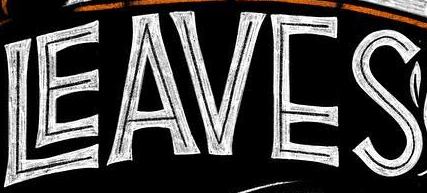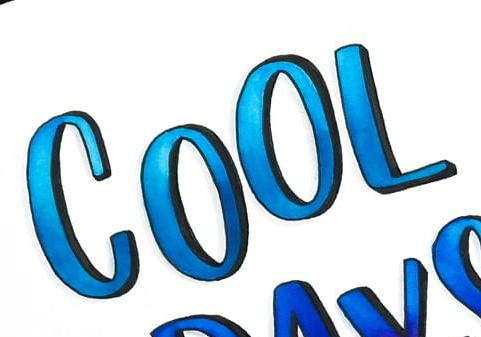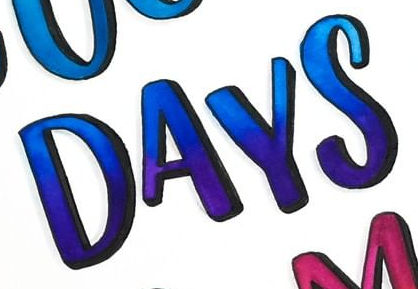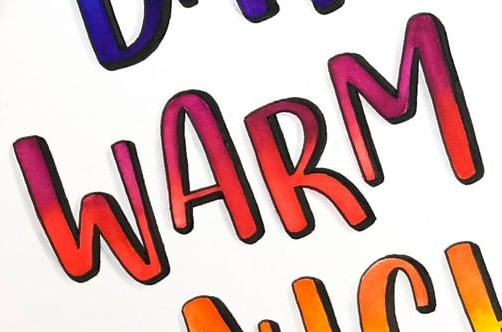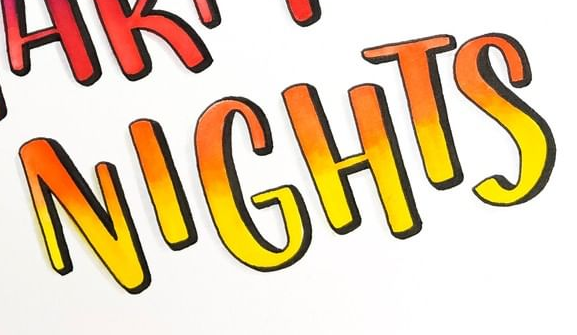What words are shown in these images in order, separated by a semicolon? LEAVES; COOL; DAYS; WARM; NIGHTS 